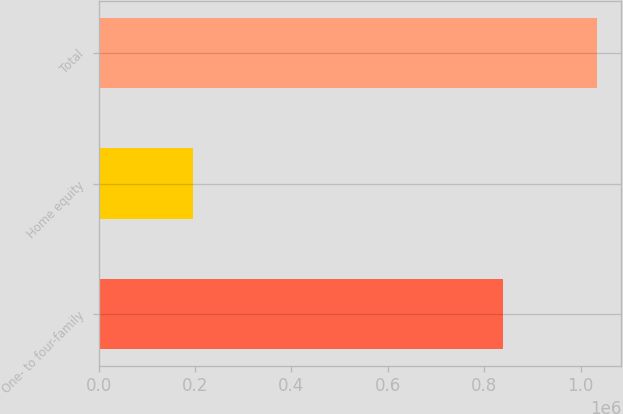Convert chart. <chart><loc_0><loc_0><loc_500><loc_500><bar_chart><fcel>One- to four-family<fcel>Home equity<fcel>Total<nl><fcel>838020<fcel>195021<fcel>1.03304e+06<nl></chart> 